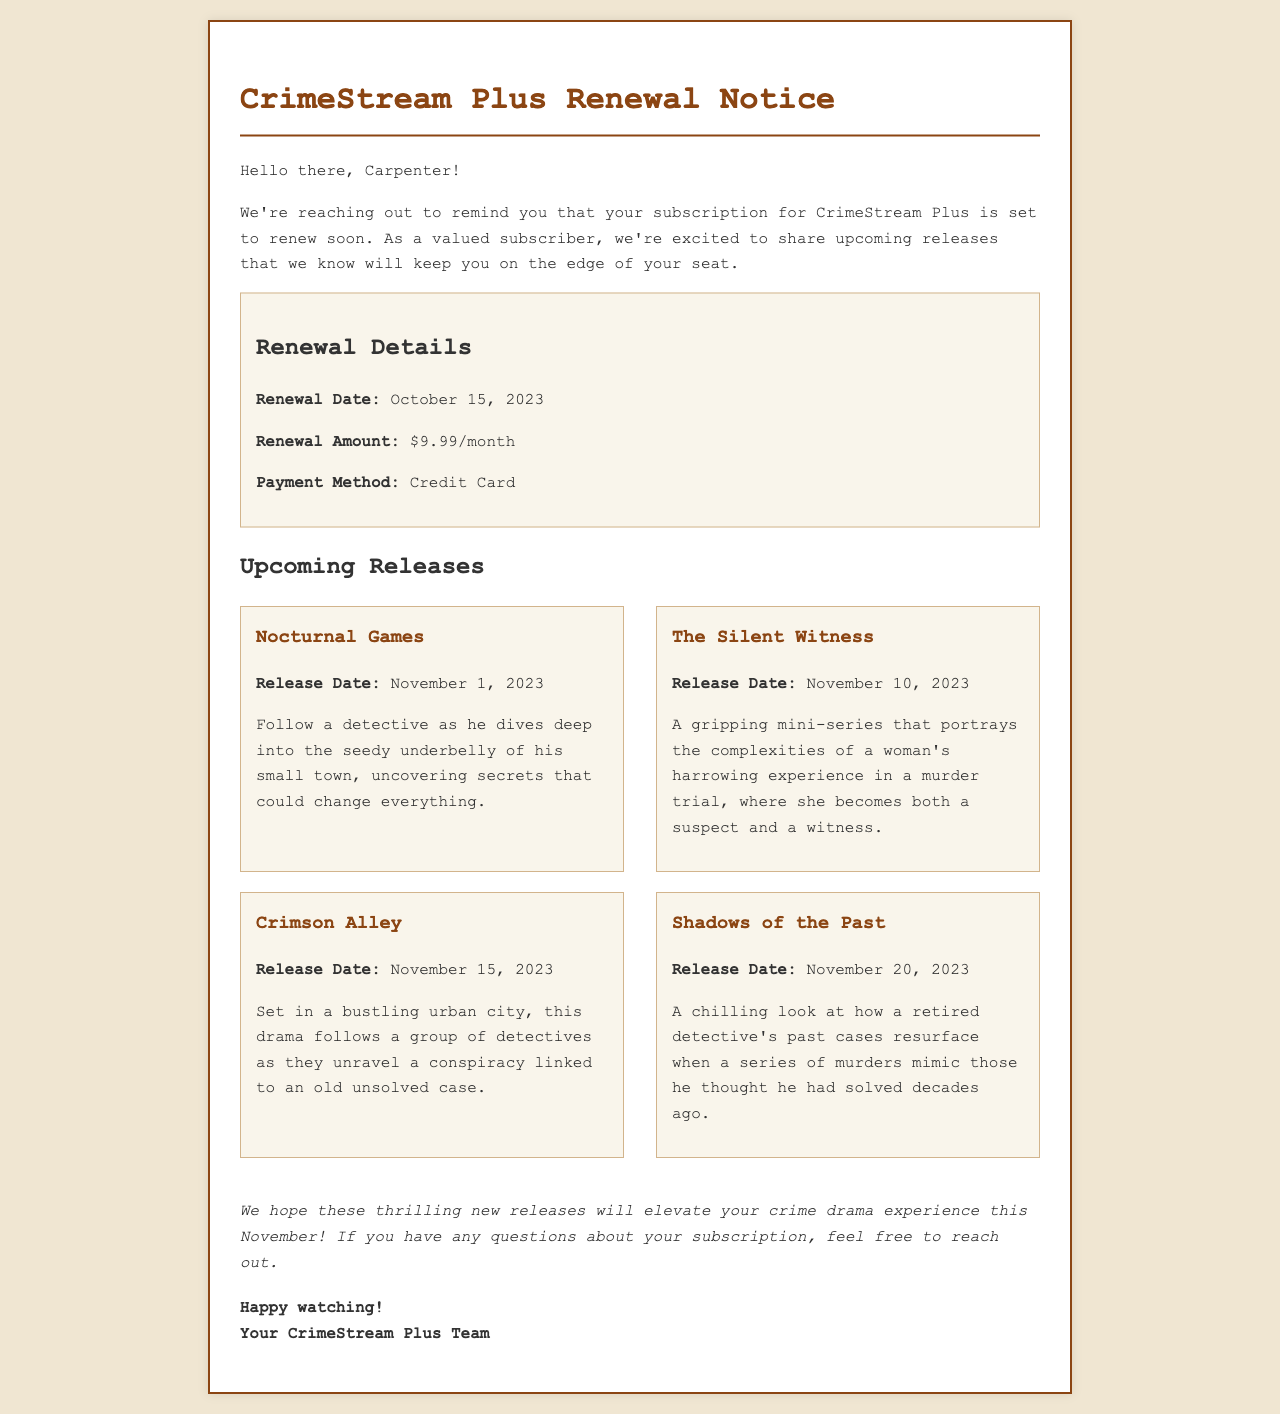What is the renewal date? The renewal date is specified clearly in the renewal details section.
Answer: October 15, 2023 What is the renewal amount? The renewal amount is mentioned in the renewal details section.
Answer: $9.99/month What is the payment method? The payment method is listed in the renewal details section.
Answer: Credit Card What is the title of the first upcoming release? The titles of the upcoming releases are highlighted under the upcoming releases section.
Answer: Nocturnal Games How many new releases are listed? The number of new releases can be counted from the upcoming releases section.
Answer: 4 Which new release has the latest release date? The latest release date can be determined by looking at the release dates for the upcoming releases.
Answer: Shadows of the Past What genre does "The Silent Witness" focus on? The document describes the specifics of each upcoming release, including their themes.
Answer: Mini-series Who is the audience of this email? The greeting at the beginning of the email indicates the intended audience.
Answer: Carpenter What should subscribers do if they have questions about their subscription? The conclusion mentions what subscribers should do if they have any inquiries.
Answer: Reach out 